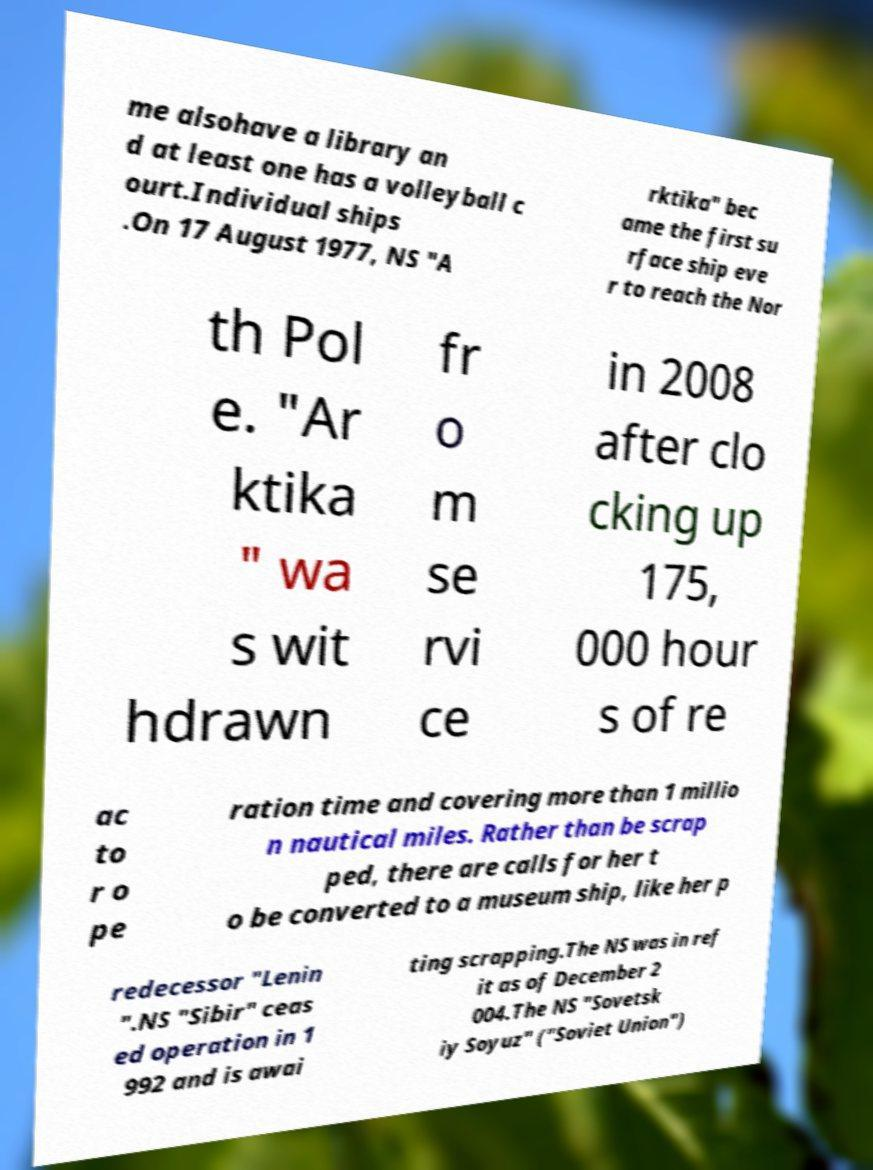Can you accurately transcribe the text from the provided image for me? me alsohave a library an d at least one has a volleyball c ourt.Individual ships .On 17 August 1977, NS "A rktika" bec ame the first su rface ship eve r to reach the Nor th Pol e. "Ar ktika " wa s wit hdrawn fr o m se rvi ce in 2008 after clo cking up 175, 000 hour s of re ac to r o pe ration time and covering more than 1 millio n nautical miles. Rather than be scrap ped, there are calls for her t o be converted to a museum ship, like her p redecessor "Lenin ".NS "Sibir" ceas ed operation in 1 992 and is awai ting scrapping.The NS was in ref it as of December 2 004.The NS "Sovetsk iy Soyuz" ("Soviet Union") 